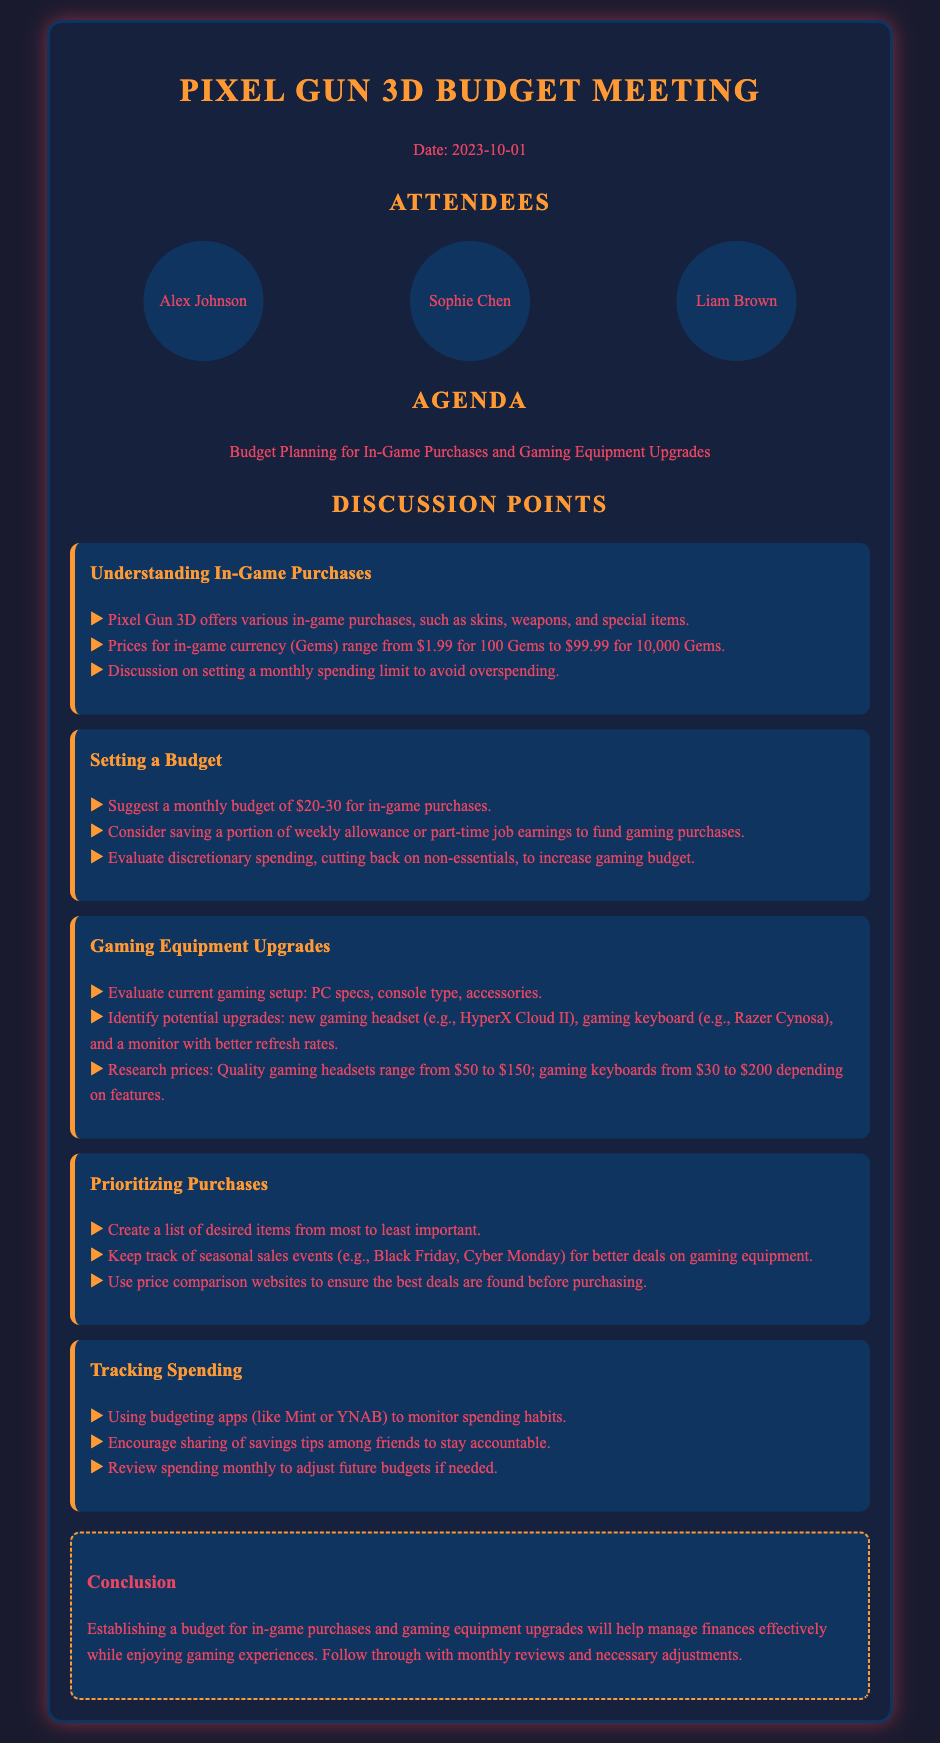What is the date of the meeting? The date of the meeting is stated prominently at the top of the document.
Answer: 2023-10-01 Who is one of the attendees? The document lists the names of participants in the "Attendees" section.
Answer: Alex Johnson What is the suggested monthly budget for in-game purchases? The document specifically mentions a range for the monthly budget in the "Setting a Budget" section.
Answer: $20-30 What is one of the potential upgrades discussed for gaming equipment? The topics in the "Gaming Equipment Upgrades" section highlight various items that could be upgraded.
Answer: gaming headset What is a method suggested for tracking spending? The document recommends specific apps for managing finances in the "Tracking Spending" section.
Answer: budgeting apps What seasonal sales events should be kept track of for better gaming deals? The document mentions specific events that could lead to better offers during purchases.
Answer: Black Friday What is the main conclusion of the meeting? The conclusion clearly summarizes the goals regarding budgeting in the last section of the document.
Answer: Establishing a budget for in-game purchases and gaming equipment upgrades will help manage finances effectively 